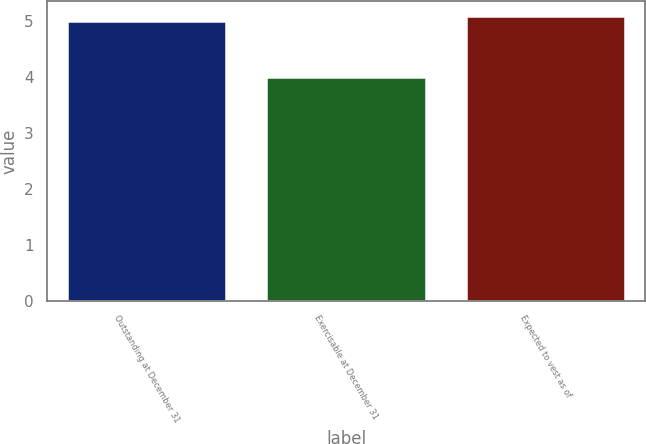<chart> <loc_0><loc_0><loc_500><loc_500><bar_chart><fcel>Outstanding at December 31<fcel>Exercisable at December 31<fcel>Expected to vest as of<nl><fcel>5<fcel>4<fcel>5.1<nl></chart> 